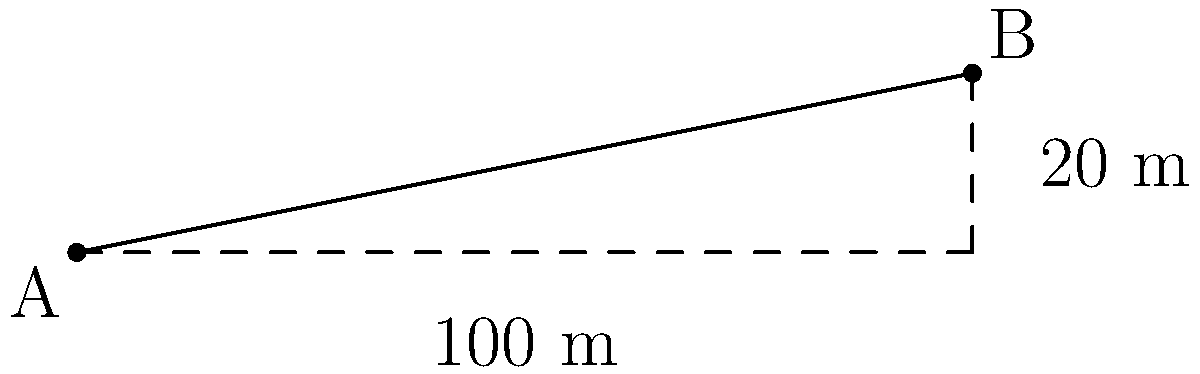During the industrial revolution in Manchester, a canal was constructed to transport goods between two points. Point A represents the starting point of the canal, and point B represents the end point. If the horizontal distance between these points is 100 meters and the vertical rise is 20 meters, calculate the slope of the canal. Express your answer as a decimal rounded to two decimal places. To calculate the slope of the canal, we need to follow these steps:

1. Recall the formula for slope:
   $$ \text{Slope} = \frac{\text{Rise}}{\text{Run}} = \frac{\text{Vertical change}}{\text{Horizontal change}} $$

2. Identify the rise and run from the given information:
   - Rise (vertical change) = 20 meters
   - Run (horizontal change) = 100 meters

3. Substitute these values into the slope formula:
   $$ \text{Slope} = \frac{20 \text{ m}}{100 \text{ m}} $$

4. Perform the division:
   $$ \text{Slope} = 0.2 $$

5. The question asks for the answer rounded to two decimal places, which is already the case here.

Therefore, the slope of the canal is 0.20 or 20%, indicating a gradual incline that would have been suitable for canal boats to navigate during the industrial revolution.
Answer: 0.20 